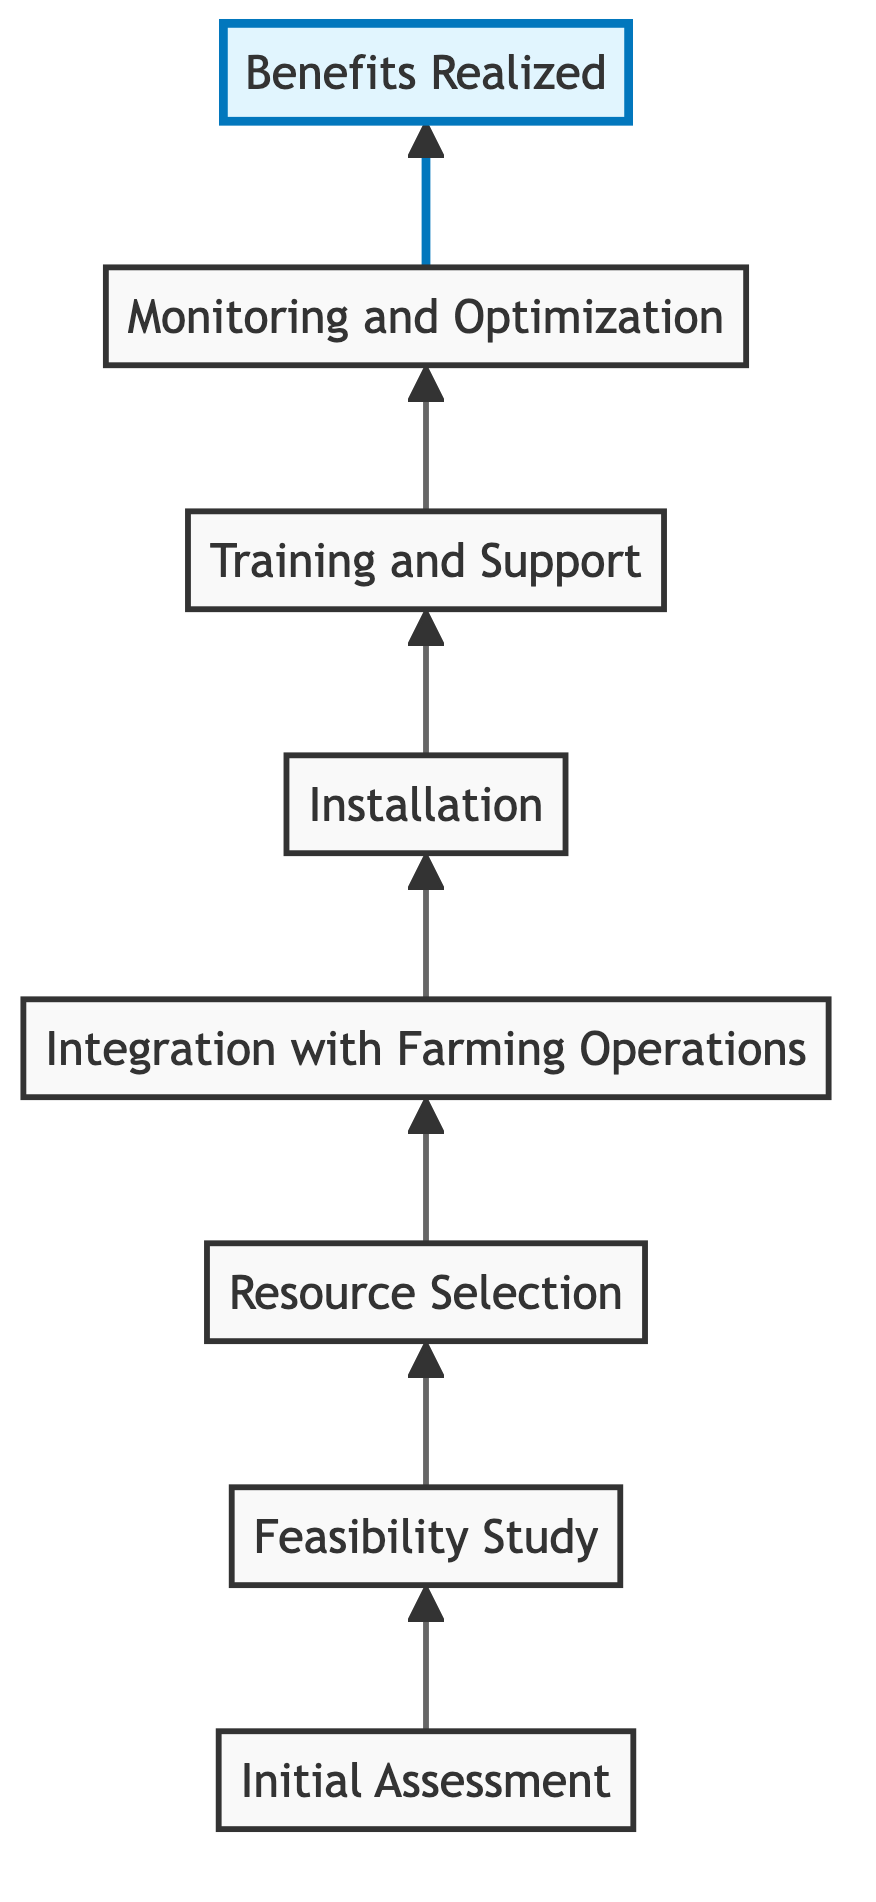What is the first step in the integration process? The diagram shows "Initial Assessment" as the first node, indicating the starting point for the integration of renewable energy in farming.
Answer: Initial Assessment How many nodes are present in the diagram? By counting each unique step from "Initial Assessment" to "Benefits Realized," we identify a total of eight nodes in the flowchart.
Answer: Eight What follows "Integration with Farming Operations"? The diagram indicates that "Installation" directly follows the node "Integration with Farming Operations," representing the next step in the process.
Answer: Installation Which node represents the advantages gained from the integration? The final node in the flowchart, "Benefits Realized," represents the advantages or outcomes resulting from the entire integration process.
Answer: Benefits Realized How many steps are involved from the "Feasibility Study" to "Benefits Realized"? Starting from "Feasibility Study" and moving through "Resource Selection," "Integration with Farming Operations," "Installation," "Training and Support," and "Monitoring and Optimization," we count a total of six steps to reach "Benefits Realized."
Answer: Six What is the last action related to the new energy systems? According to the flowchart, the final action tied to the renewable energy systems is "Monitoring and Optimization," which focuses on tracking performance after installation.
Answer: Monitoring and Optimization Which node highlights the end goal of the entire process? The node "Benefits Realized" is highlighted in the diagram, emphasizing it as the ultimate achievement of the integration process.
Answer: Benefits Realized What is the relationship between "Training and Support" and "Monitoring and Optimization"? The relationship between these two nodes is sequential; "Training and Support" leads directly into "Monitoring and Optimization," showing that training occurs before performance tracking.
Answer: Sequential 